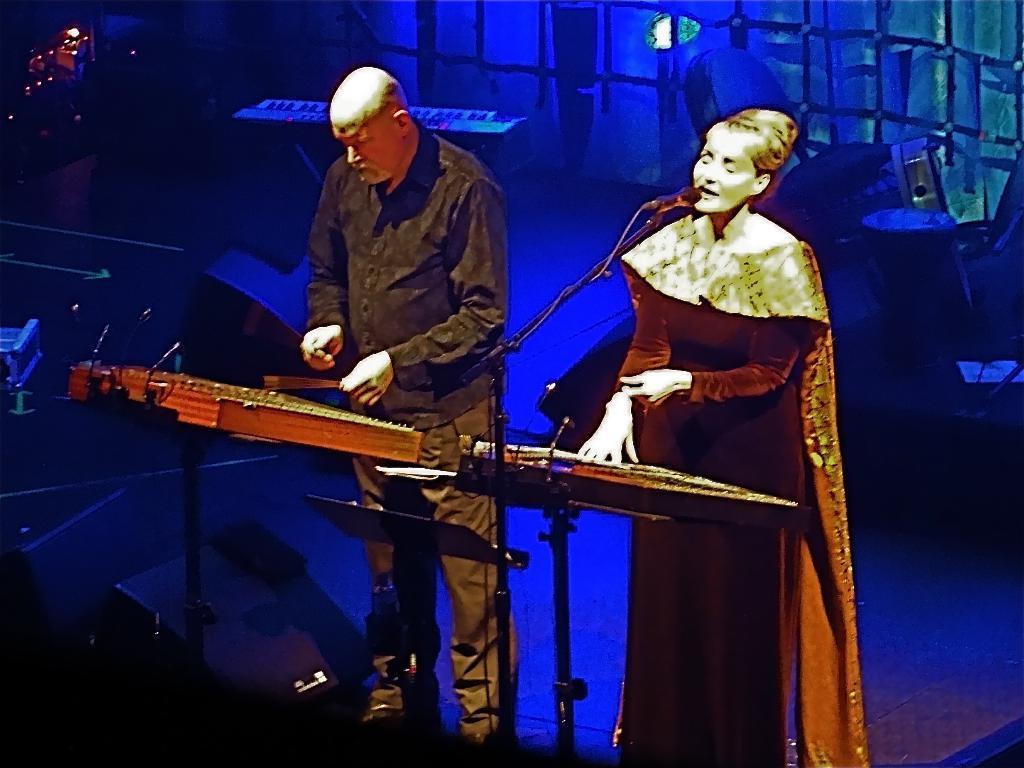How would you summarize this image in a sentence or two? This picture shows a woman and a man playing musical instruments and we see woman singing with the help of a microphone and we see few musical instruments on the back. 